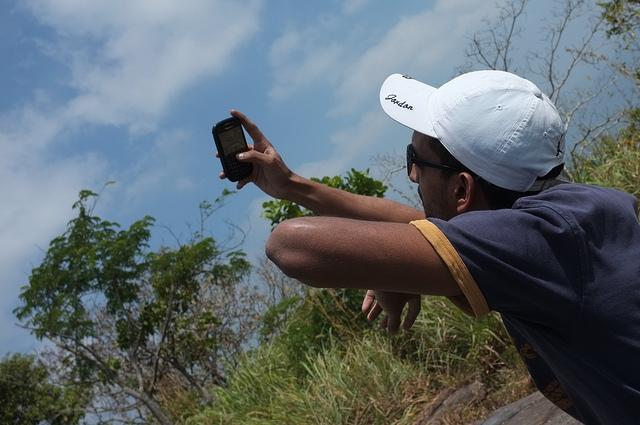Is he wearing a hat?
Quick response, please. Yes. Is he wearing sunglasses?
Answer briefly. Yes. What is he holding in his hand?
Write a very short answer. Phone. 